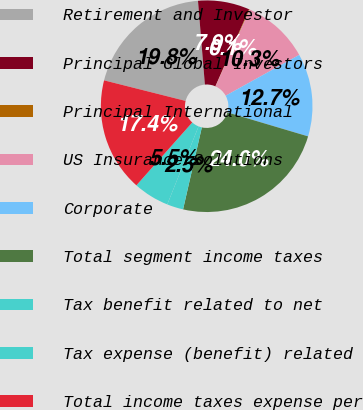<chart> <loc_0><loc_0><loc_500><loc_500><pie_chart><fcel>Retirement and Investor<fcel>Principal Global Investors<fcel>Principal International<fcel>US Insurance Solutions<fcel>Corporate<fcel>Total segment income taxes<fcel>Tax benefit related to net<fcel>Tax expense (benefit) related<fcel>Total income taxes expense per<nl><fcel>19.76%<fcel>7.88%<fcel>0.1%<fcel>10.27%<fcel>12.66%<fcel>23.98%<fcel>2.49%<fcel>5.49%<fcel>17.37%<nl></chart> 